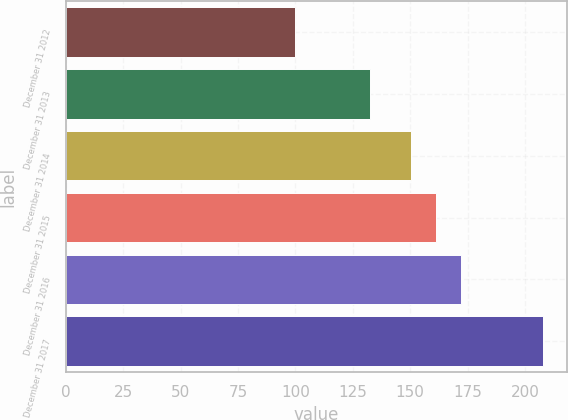Convert chart. <chart><loc_0><loc_0><loc_500><loc_500><bar_chart><fcel>December 31 2012<fcel>December 31 2013<fcel>December 31 2014<fcel>December 31 2015<fcel>December 31 2016<fcel>December 31 2017<nl><fcel>100<fcel>132.4<fcel>150.5<fcel>161.31<fcel>172.12<fcel>208.1<nl></chart> 